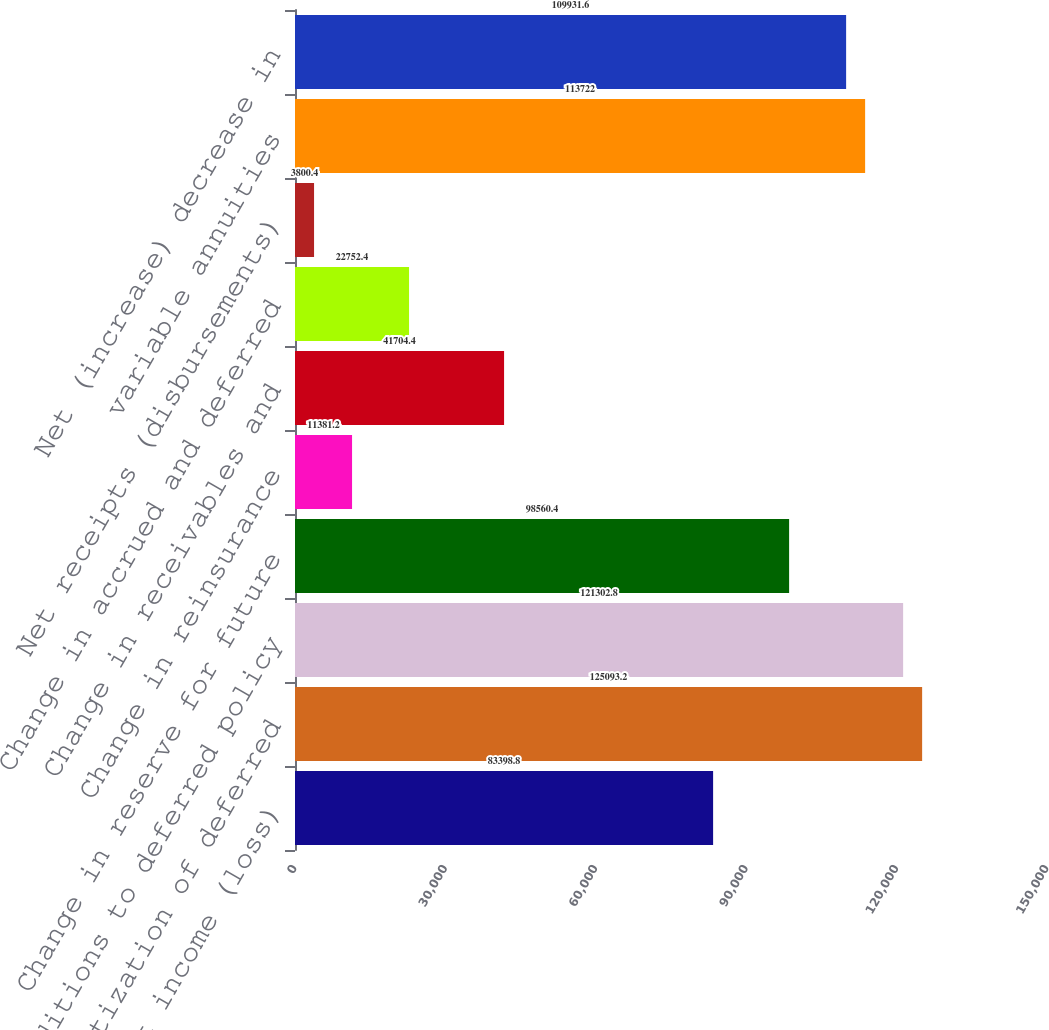<chart> <loc_0><loc_0><loc_500><loc_500><bar_chart><fcel>Net income (loss)<fcel>Amortization of deferred<fcel>Additions to deferred policy<fcel>Change in reserve for future<fcel>Change in reinsurance<fcel>Change in receivables and<fcel>Change in accrued and deferred<fcel>Net receipts (disbursements)<fcel>variable annuities<fcel>Net (increase) decrease in<nl><fcel>83398.8<fcel>125093<fcel>121303<fcel>98560.4<fcel>11381.2<fcel>41704.4<fcel>22752.4<fcel>3800.4<fcel>113722<fcel>109932<nl></chart> 